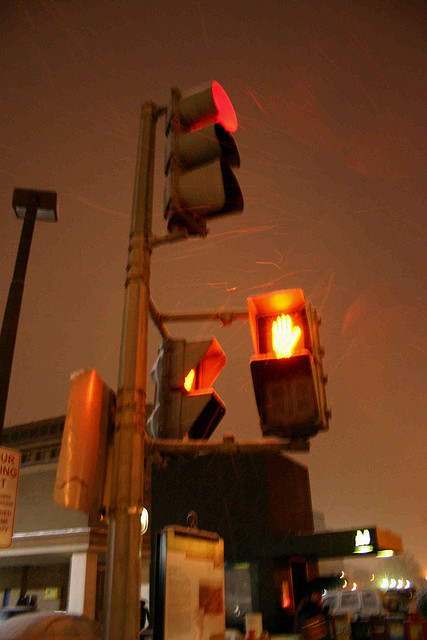Is this the country? No, the setting is not in the countryside; it depicts an urban environment, considering the presence of traffic signals and artificial lighting. 